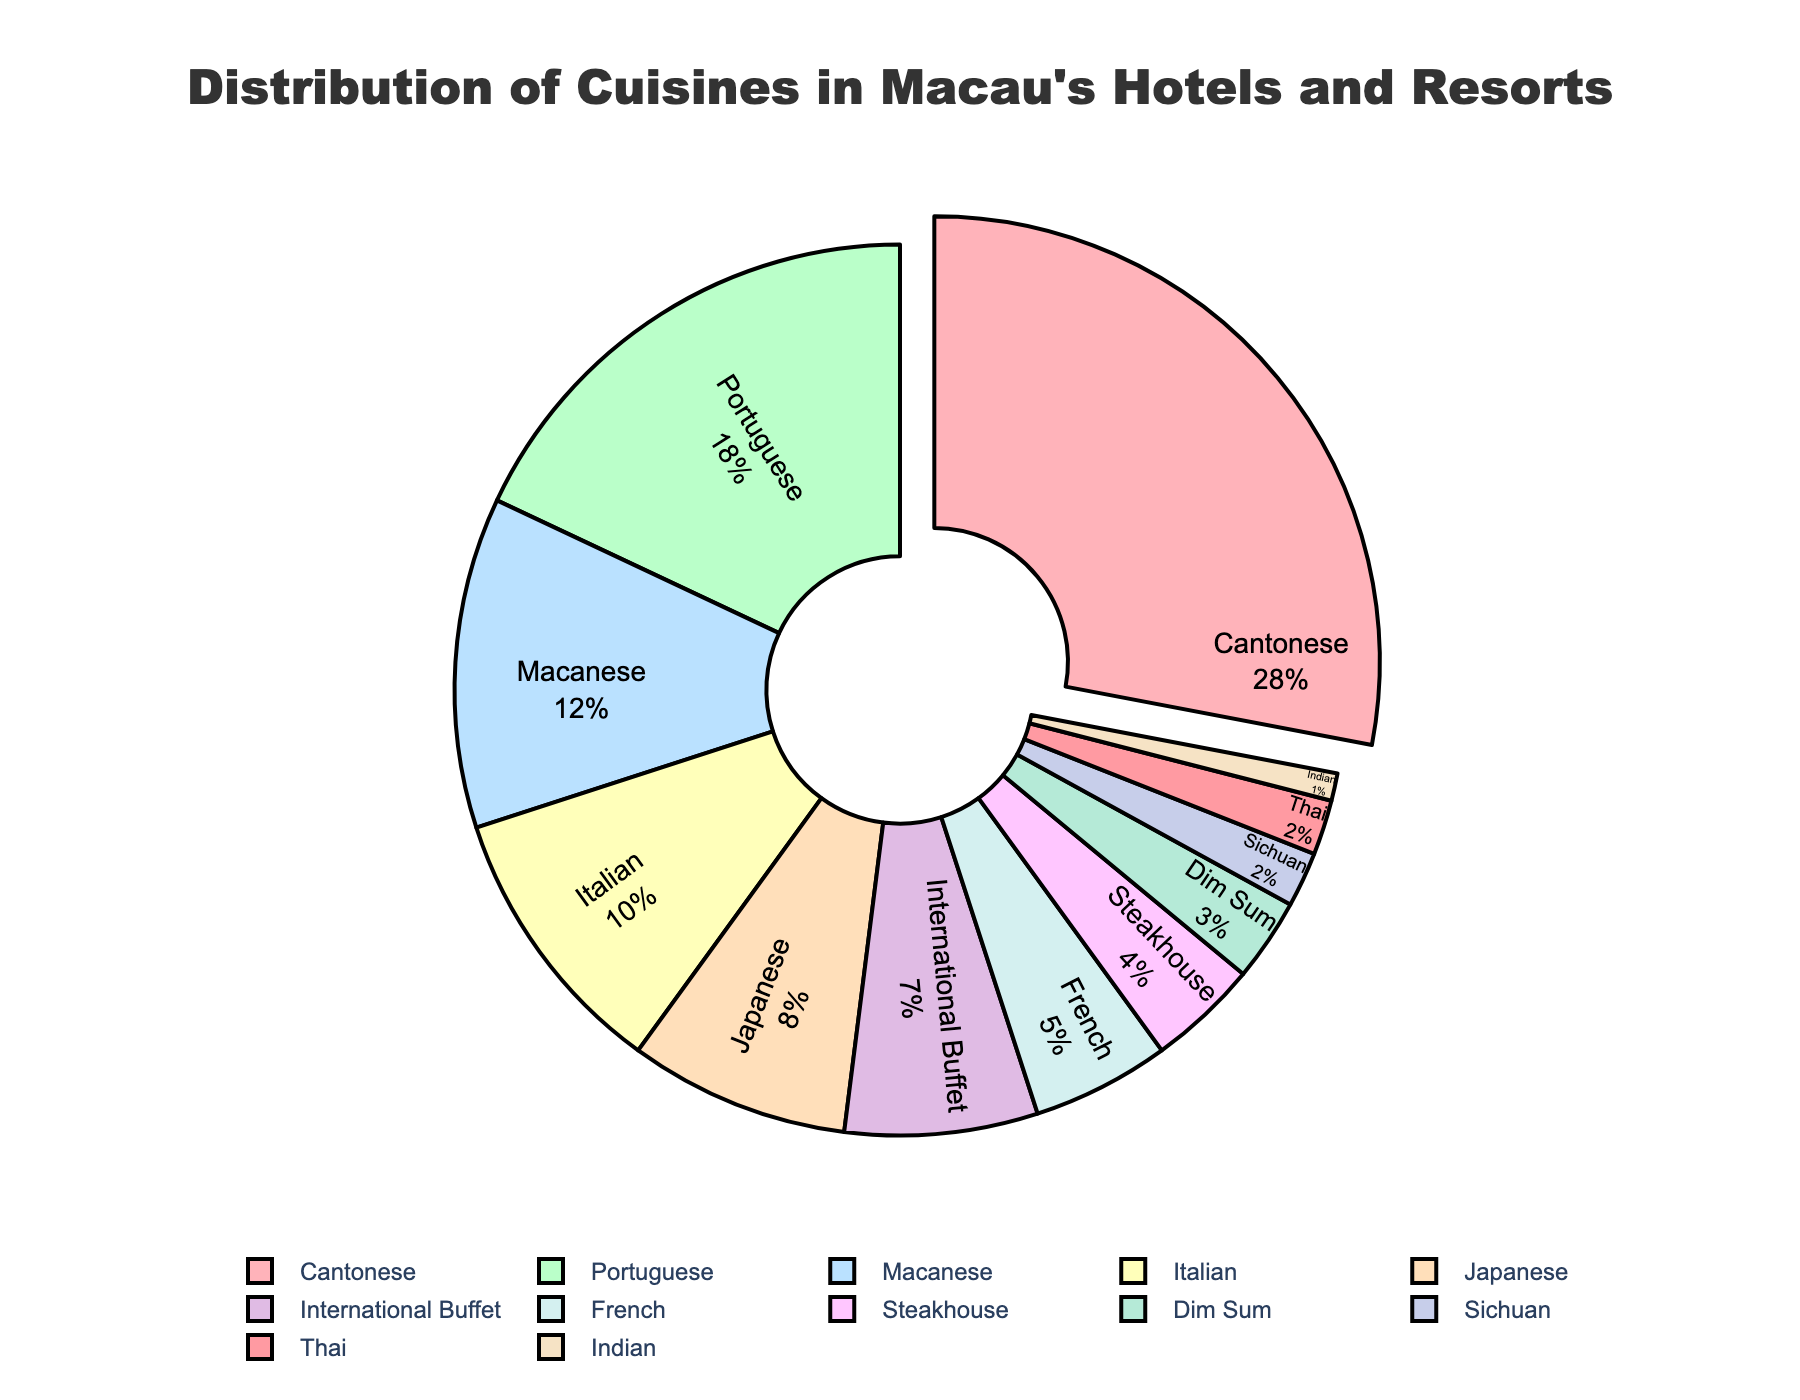Which cuisine is the most prevalent in Macau's hotels and resorts? The slice of the pie chart pulled out from the rest indicates which cuisine has the highest percentage. Referring to the chart, Cantonese cuisine is the most prevalent.
Answer: Cantonese What is the combined percentage of Portuguese and Macanese cuisines? To find the combined percentage, look at the percentages of Portuguese (18%) and Macanese (12%) cuisines and add them together. 18 + 12 = 30
Answer: 30% How does the percentage of Japanese cuisine compare to Italian cuisine? Compare the size of the slices corresponding to Japanese (8%) and Italian (10%) cuisines. Japanese has a smaller percentage than Italian.
Answer: Italian is 2% higher than Japanese Which cuisines have the smallest and second smallest percentages in the chart? Look for the smallest slices of the pie. The smallest percentage is for Indian cuisine (1%) followed by Thai cuisine (2%).
Answer: Indian and Thai What is the percentage difference between Cantonese and Portuguese cuisines? Calculate the difference between Cantonese (28%) and Portuguese (18%) percentages. 28 - 18 = 10
Answer: 10% Which three cuisines combined make up less than 10% of the total distribution? Look for cuisines with small percentages and add their values. Dim Sum (3%), Sichuan (2%), and Indian (1%) combined equal 6%, which is less than 10%.
Answer: Dim Sum, Sichuan, and Indian Calculate the average percentage of the top four cuisines. Add the percentages of the top four cuisines and divide by four. (Cantonese 28% + Portuguese 18% + Macanese 12% + Italian 10%) / 4 = 68 / 4 = 17
Answer: 17% Which cuisine has the second highest percentage, and what visual cue indicates it? The second largest slice of the pie chart belongs to Portuguese cuisine, indicated by its size.
Answer: Portuguese If International Buffet and French cuisines were combined, what would their combined percentage be? Add the percentages of International Buffet (7%) and French (5%) cuisines. 7 + 5 = 12
Answer: 12% Which colors represent the Cantonese and Portuguese cuisines on the pie chart? Cantonese is represented by the largest slice which is in pink, and Portuguese is the second largest slice in green.
Answer: Pink and Green 